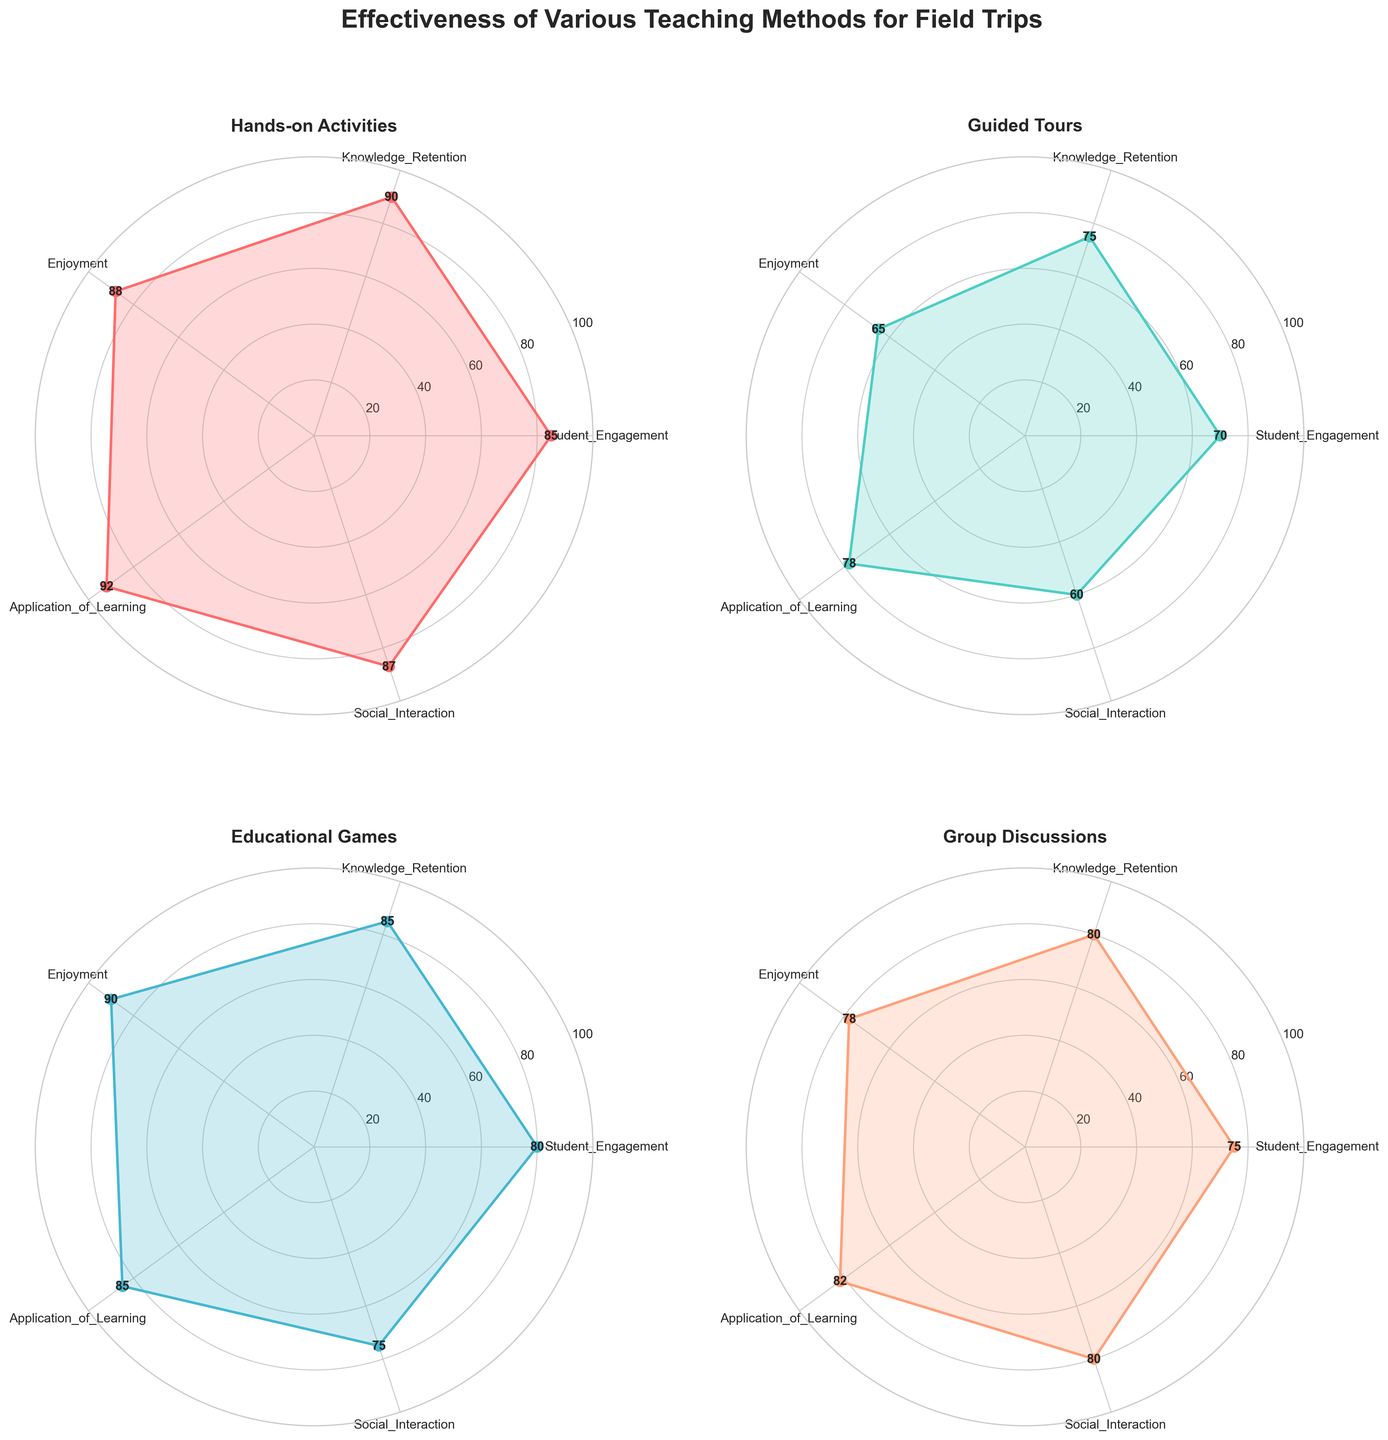What is the title of the figure? The title of the figure is displayed at the top of the subplot.
Answer: Effectiveness of Various Teaching Methods for Field Trips Which teaching method has the highest value for Knowledge Retention? Look at the "Knowledge Retention" axis and check which teaching method has the highest value.
Answer: Hands-on Activities Which teaching method scores the lowest in Student Engagement? Look at the values along the "Student Engagement" axis and identify the method with the lowest score.
Answer: Guided Tours For Hands-on Activities, what is the sum of all the values? Sum the values of Hands-on Activities' ratings across all categories: 85+90+88+92+87.
Answer: 442 Which teaching method has the most balanced scores across all categories? Look for the teaching method whose radar chart is the most circular and evenly spread out.
Answer: Group Discussions How much higher is Student Engagement in Hands-on Activities compared to Guided Tours? Subtract the Student Engagement value of Guided Tours from that of Hands-on Activities (85 - 70).
Answer: 15 Between Educational Games and Group Discussions, which method has better Social Interaction? Compare the scores for "Social Interaction" between Educational Games and Group Discussions.
Answer: Group Discussions What is the average score of Enjoyment for Guided Tours and Educational Games? Calculate the average of Enjoyment scores: (65 + 90)/2.
Answer: 77.5 Which category has the smallest range of values among the teaching methods? Determine the difference between the highest and lowest values for each category and identify the smallest difference.
Answer: Social Interaction Compare the Application of Learning score between Hands-on Activities and Group Discussions. Which one is higher? Look at the "Application of Learning" scores for Hands-on Activities and Group Discussions and compare.
Answer: Hands-on Activities 